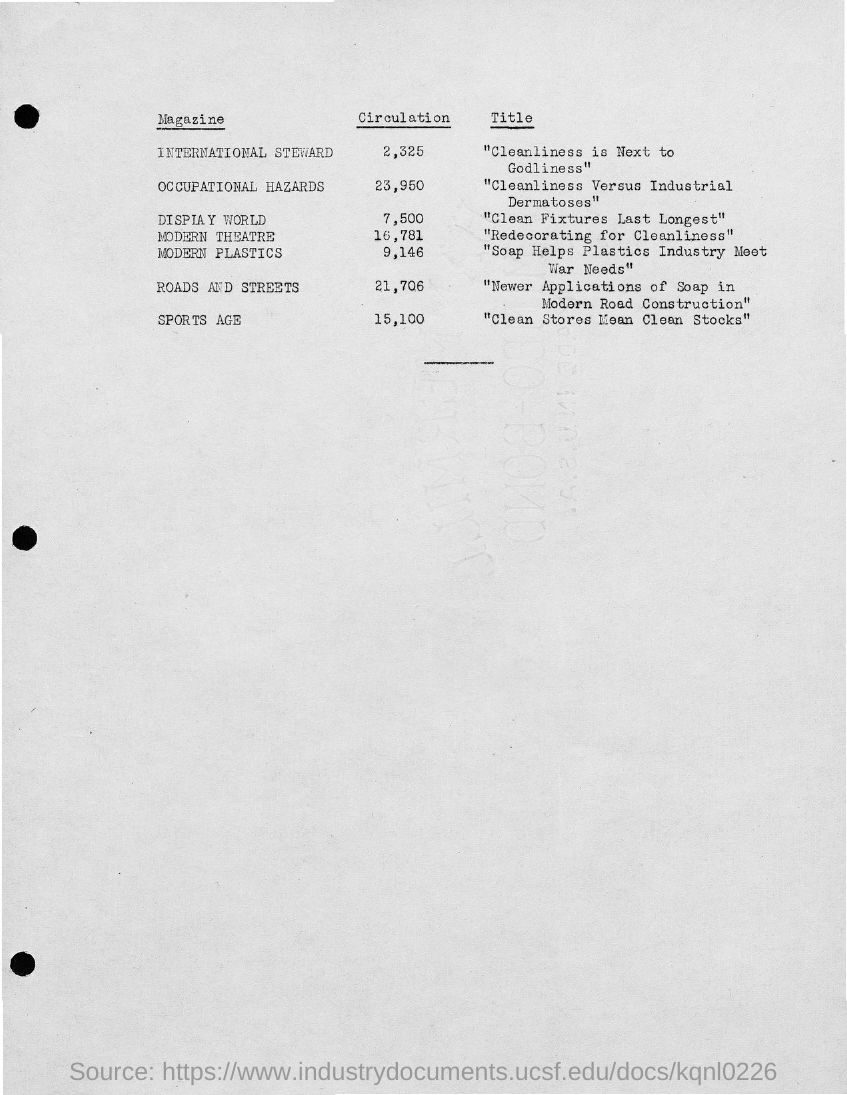Outline some significant characteristics in this image. The magazine with a circulation of 15,100 is named Sports Age. The magazine with a circulation of 21,706, dedicated to roads and streets, is named [Name of the magazine]. 